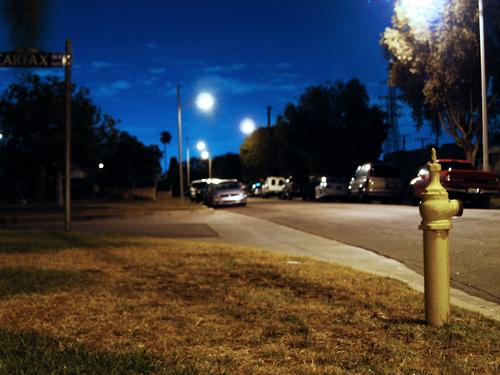Where are the cars parked?
Give a very brief answer. Street. Is the moon visible in this picture?
Give a very brief answer. No. What color is the hydrant?
Give a very brief answer. Yellow. Is this image rural?
Answer briefly. No. Is this a one-way street?
Concise answer only. No. 